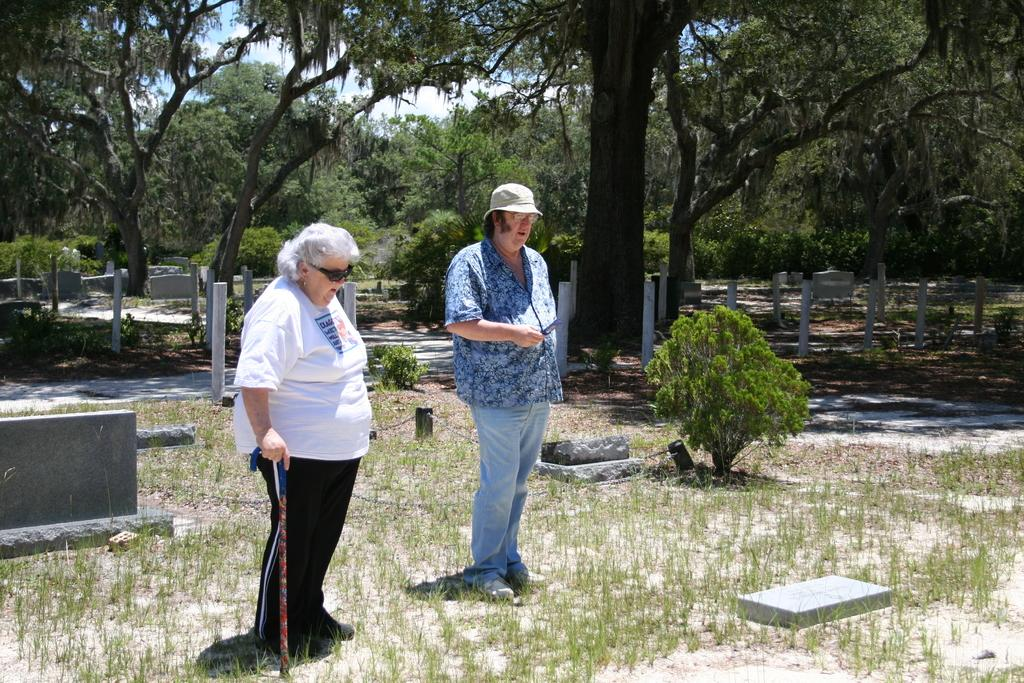How many people are in the image? There are two persons standing in the middle of the image. What can be seen in the background of the image? There are trees visible at the back side of the image. What is visible at the top of the image? The sky is visible at the top of the image. What color is the crayon being used by one of the persons in the image? There is no crayon present in the image; it only features two persons standing in the middle of the image. 